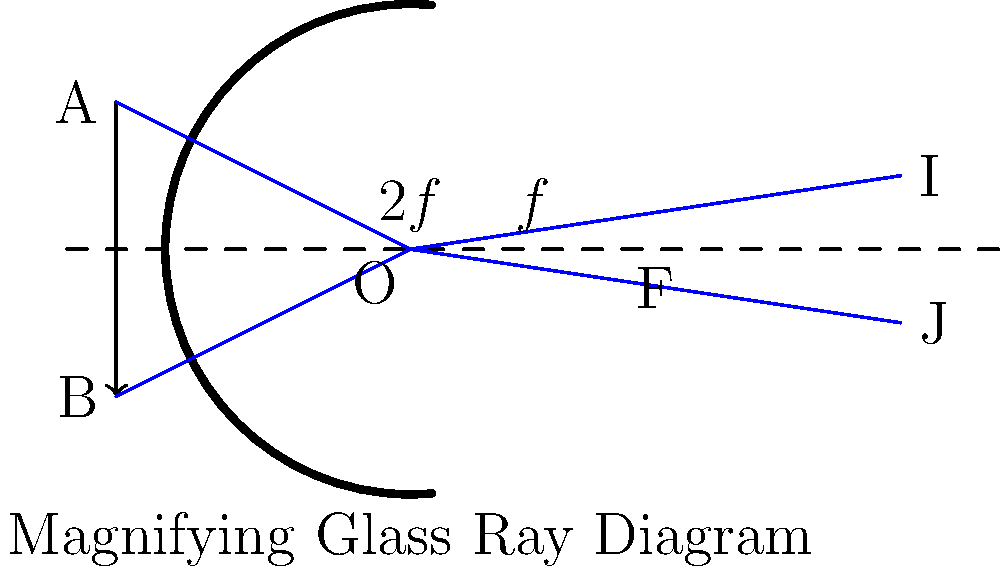In the ray diagram of a magnifying glass used by medieval scholars, an object AB is placed at a distance less than the focal length $f$ from the lens. Explain why the image IJ appears to be on the same side of the lens as the object, and why it appears larger and upright. How does this optical principle relate to the ability of medieval scholars to examine fine details in manuscripts? 1. Object position: The object AB is placed between the focal point F and the lens (at a distance less than $f$).

2. Ray tracing:
   a. Rays from point A pass through the lens and diverge.
   b. Rays from point B also pass through the lens and diverge.
   c. These diverging rays cannot meet on the other side of the lens.

3. Virtual image formation:
   a. The brain perceives these diverging rays as if they originated from points I and J behind the lens.
   b. This creates a virtual image IJ on the same side of the lens as the object.

4. Image characteristics:
   a. The image is upright because it is on the same side as the object.
   b. The image is larger than the object (magnified) because it is formed farther from the lens than the object.

5. Magnification:
   The magnification $M$ is given by $M = \frac{d_i}{d_o}$, where $d_i$ is the image distance and $d_o$ is the object distance. Since $d_i > d_o$, $M > 1$.

6. Application to medieval scholarship:
   This optical principle allowed medieval scholars to examine fine details in manuscripts by magnifying small text or intricate illustrations. The ability to see enlarged, upright images of small objects significantly aided in the study and preservation of historical texts.

7. Relation to the Gutenberg printing press:
   The same optical principles were crucial in the development and use of the Gutenberg printing press, as they allowed for the precise examination of type blocks and printed pages, ensuring high-quality reproductions.
Answer: Virtual, enlarged, and upright image formation enables detailed manuscript examination. 